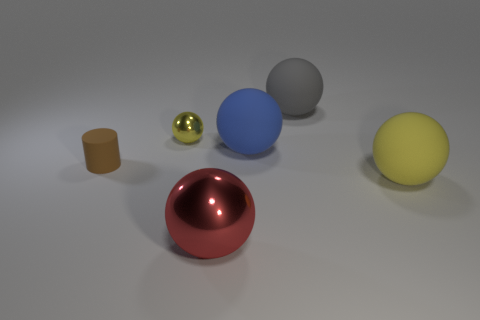Subtract all big gray matte spheres. How many spheres are left? 4 Subtract all blue spheres. How many spheres are left? 4 Subtract all blue balls. Subtract all cyan blocks. How many balls are left? 4 Add 4 small purple rubber cubes. How many objects exist? 10 Subtract all spheres. How many objects are left? 1 Subtract 1 red balls. How many objects are left? 5 Subtract all small yellow cubes. Subtract all metal objects. How many objects are left? 4 Add 5 large blue balls. How many large blue balls are left? 6 Add 3 brown cylinders. How many brown cylinders exist? 4 